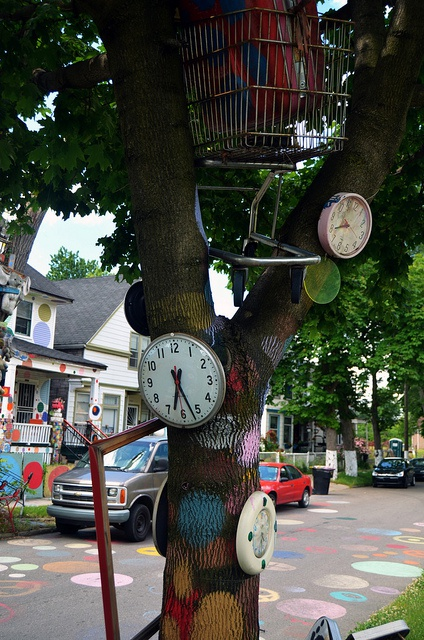Describe the objects in this image and their specific colors. I can see car in black, gray, lightgray, and darkgray tones, clock in black, darkgray, and gray tones, clock in black, darkgray, and gray tones, clock in black, darkgray, lightgray, and gray tones, and car in black, brown, red, and salmon tones in this image. 